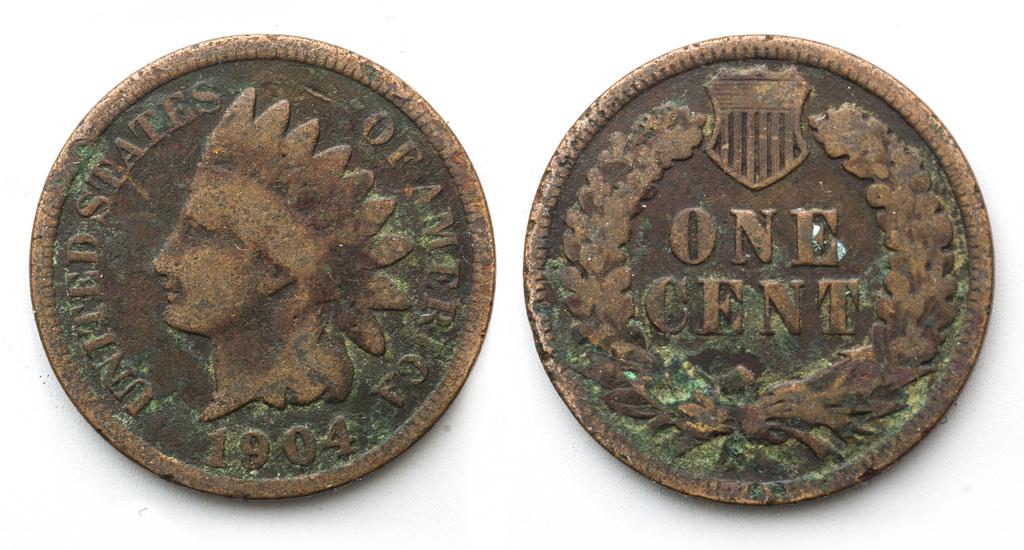Provide a one-sentence caption for the provided image. The front and backside of a penny that is from the year 1904. 